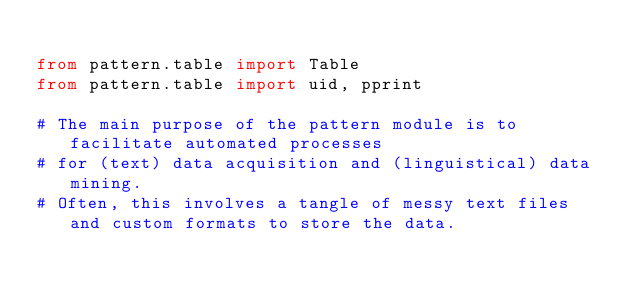Convert code to text. <code><loc_0><loc_0><loc_500><loc_500><_Python_>
from pattern.table import Table
from pattern.table import uid, pprint

# The main purpose of the pattern module is to facilitate automated processes
# for (text) data acquisition and (linguistical) data mining.
# Often, this involves a tangle of messy text files and custom formats to store the data.</code> 